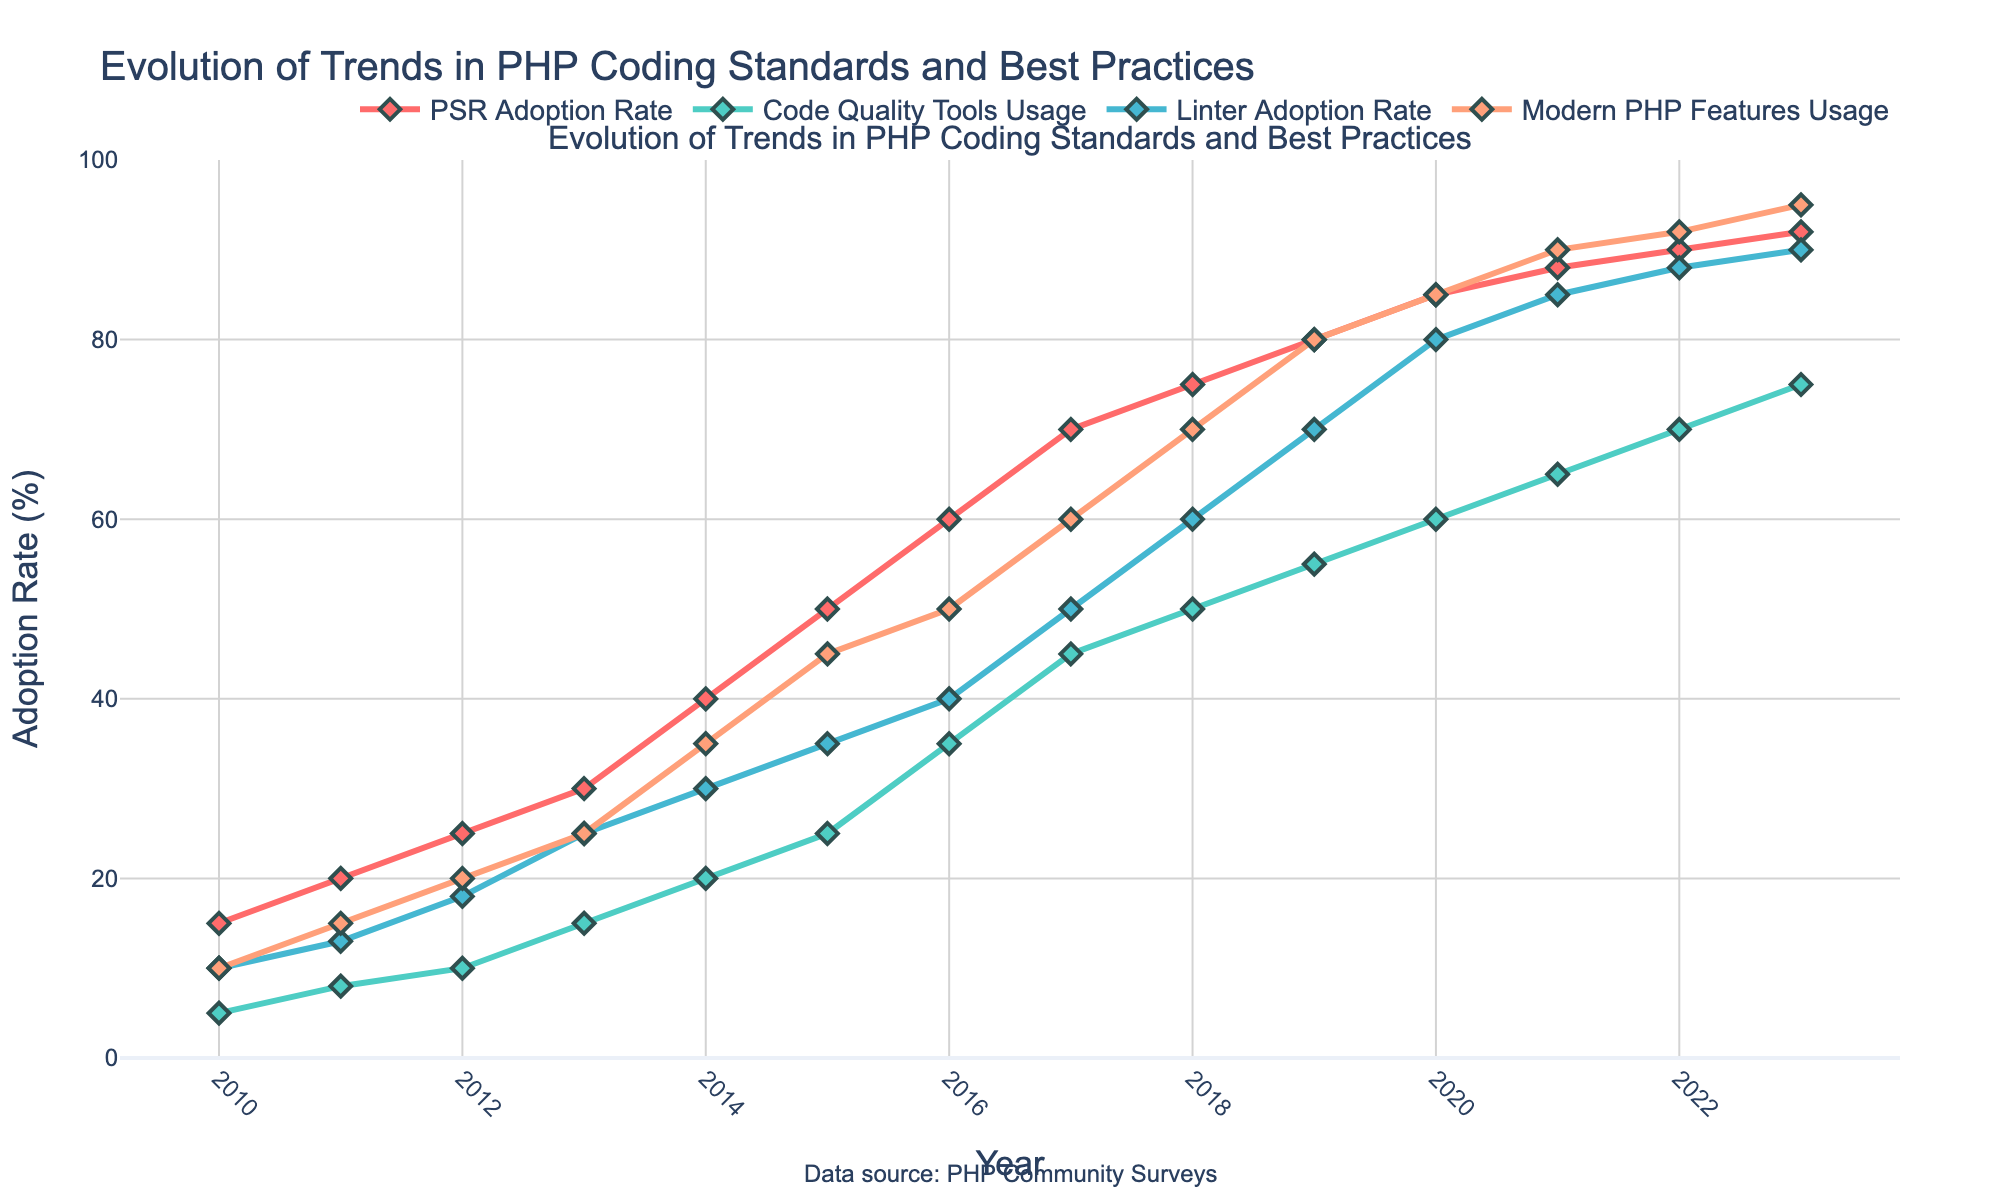Which trend saw the highest adoption rate in 2023? By examining the data points for each trend in 2023, we see that 'Modern PHP Features Usage' has an adoption rate of 95%, which is the highest among all the trends.
Answer: Modern PHP Features Usage What is the title of the plot? The title is displayed at the top of the plot, stating the focus of the visual representation.
Answer: Evolution of Trends in PHP Coding Standards and Best Practices How did the PSR Adoption Rate change from 2010 to 2023? The PSR Adoption Rate can be observed on the y-axis, comparing its value at the start (2010) and end (2023) years. It increased from 15% in 2010 to 92% in 2023.
Answer: Increased from 15% to 92% Which year showed the first significant jump for Code Quality Tools Usage, exceeding 30%? By tracking the trend for Code Quality Tools Usage over the years, the year 2016 is the first where the rate exceeds 30%, specifically reaching 35%.
Answer: 2016 Between 2015 and 2020, which trend had the greatest percentage increase? By calculating the difference between 2015 and 2020 for each trend, we find:
- PSR: 85% - 50% = 35%
- Code Quality Tools: 60% - 25% = 35%
- Linter: 80% - 35% = 45%
- Modern PHP Features: 85% - 45% = 40%
The Linter Adoption Rate showed the greatest increase of 45%.
Answer: Linter Adoption Rate How many different colors are used to represent different trends in the plot? By visually inspecting the lines and markers, we see four different colors representing each of the four trends.
Answer: Four What was the Linter Adoption Rate in 2014 compared to the Code Quality Tools Usage in 2019? Checking the values:
- Linter Adoption Rate in 2014: 30%
- Code Quality Tools Usage in 2019: 55%
So, Code Quality Tools Usage in 2019 is higher.
Answer: Code Quality Tools Usage in 2019 What is the average adoption rate of Modern PHP Features from 2010 to 2023? Summing up all the adoption rates for Modern PHP Features from 2010 to 2023 and dividing by the number of years (14), we get:
(10 + 15 + 20 + 25 + 35 + 45 + 50 + 60 + 70 + 80 + 85 + 90 + 92 + 95) / 14 = 55.71%
Answer: 55.71% Which year marked the beginning of a consistent increase in PSR Adoption Rate, showing no decline thereafter? Observing the PSR Adoption Rate data points, we see that from 2010 onward, it consistently increased every year without any decline.
Answer: 2010 Was the adoption rate of Code Quality Tools ever higher than the Linter Adoption Rate? By comparing the yearly values of Code Quality Tools Usage and Linter Adoption Rate, we find that Code Quality Tools was never higher than Linter Adoption in any year.
Answer: No 